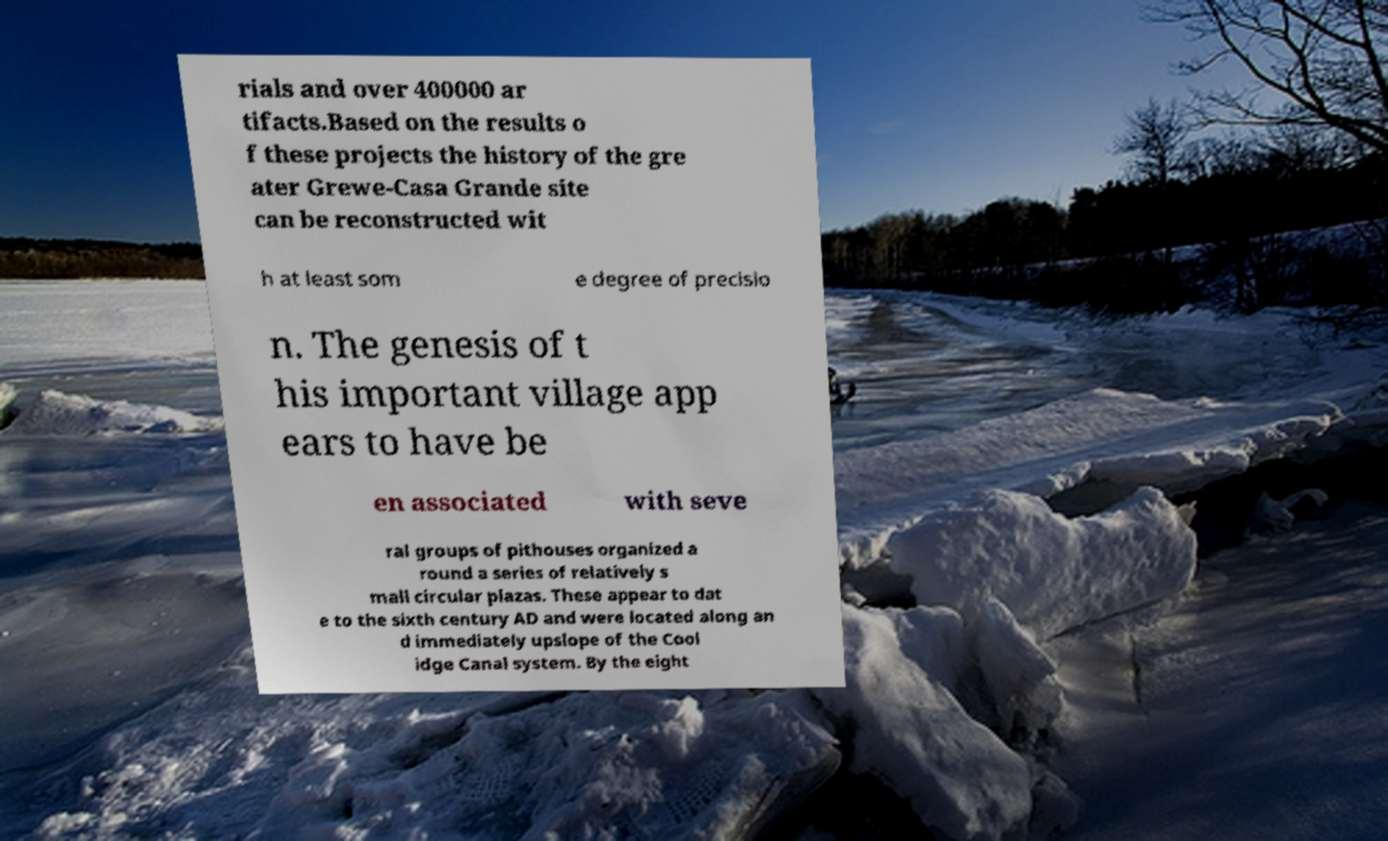Please identify and transcribe the text found in this image. rials and over 400000 ar tifacts.Based on the results o f these projects the history of the gre ater Grewe-Casa Grande site can be reconstructed wit h at least som e degree of precisio n. The genesis of t his important village app ears to have be en associated with seve ral groups of pithouses organized a round a series of relatively s mall circular plazas. These appear to dat e to the sixth century AD and were located along an d immediately upslope of the Cool idge Canal system. By the eight 